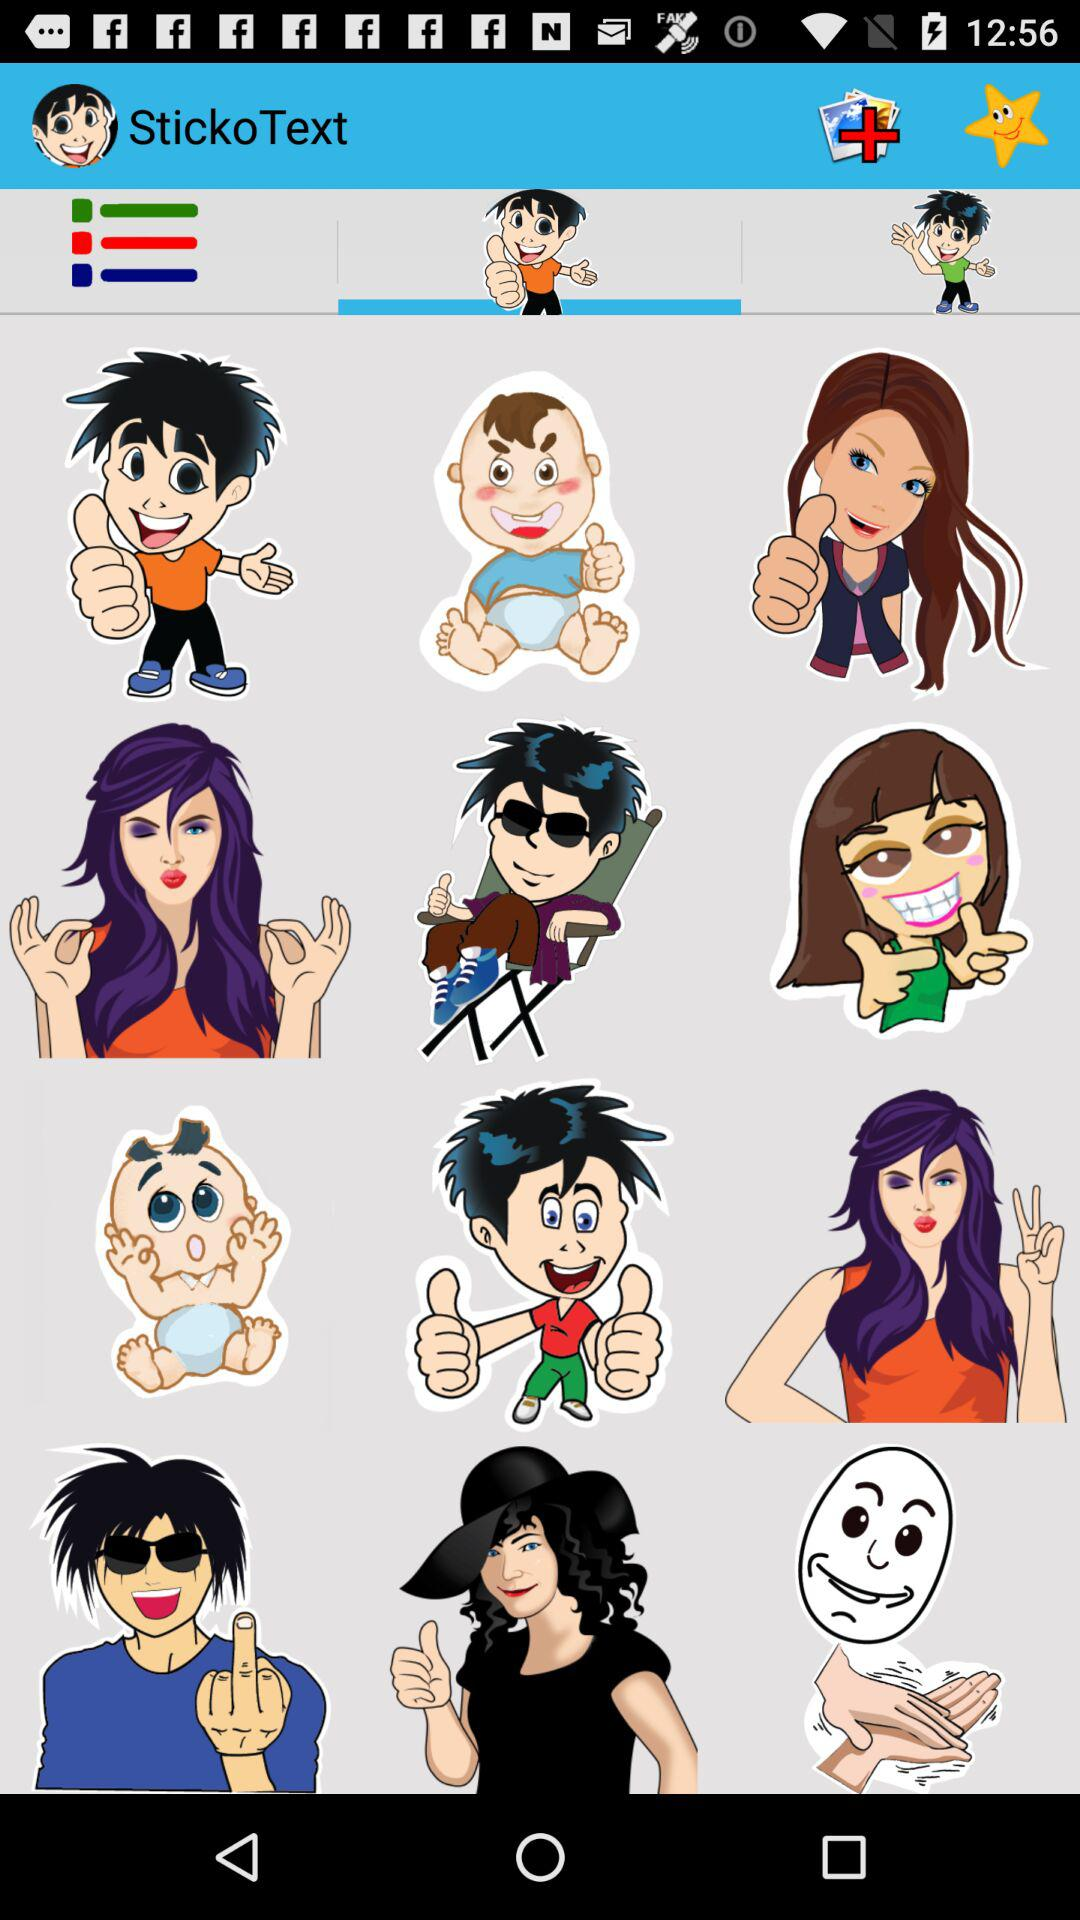What is the name of the application? The name of the application is "StickoText". 